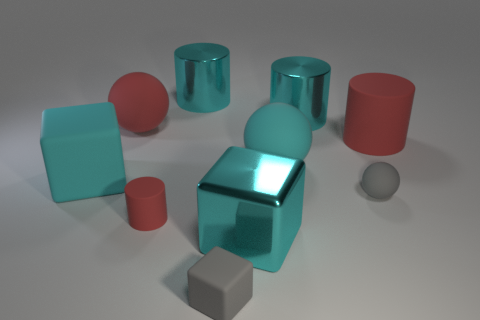What number of blue objects are either large metal cylinders or small matte things?
Your answer should be very brief. 0. There is a cyan ball that is the same material as the large red cylinder; what is its size?
Your answer should be very brief. Large. Do the big cyan ball that is behind the gray sphere and the large cyan block that is on the right side of the tiny block have the same material?
Provide a short and direct response. No. What number of spheres are cyan rubber things or matte things?
Provide a succinct answer. 3. How many small matte things are to the left of the small rubber object that is to the right of the big cyan metal object that is to the right of the large cyan sphere?
Make the answer very short. 2. What material is the big red thing that is the same shape as the small red object?
Make the answer very short. Rubber. Is there anything else that is made of the same material as the tiny sphere?
Your response must be concise. Yes. What color is the matte cylinder in front of the big red cylinder?
Provide a succinct answer. Red. Does the big red ball have the same material as the red cylinder behind the cyan matte sphere?
Offer a very short reply. Yes. What material is the big red cylinder?
Keep it short and to the point. Rubber. 